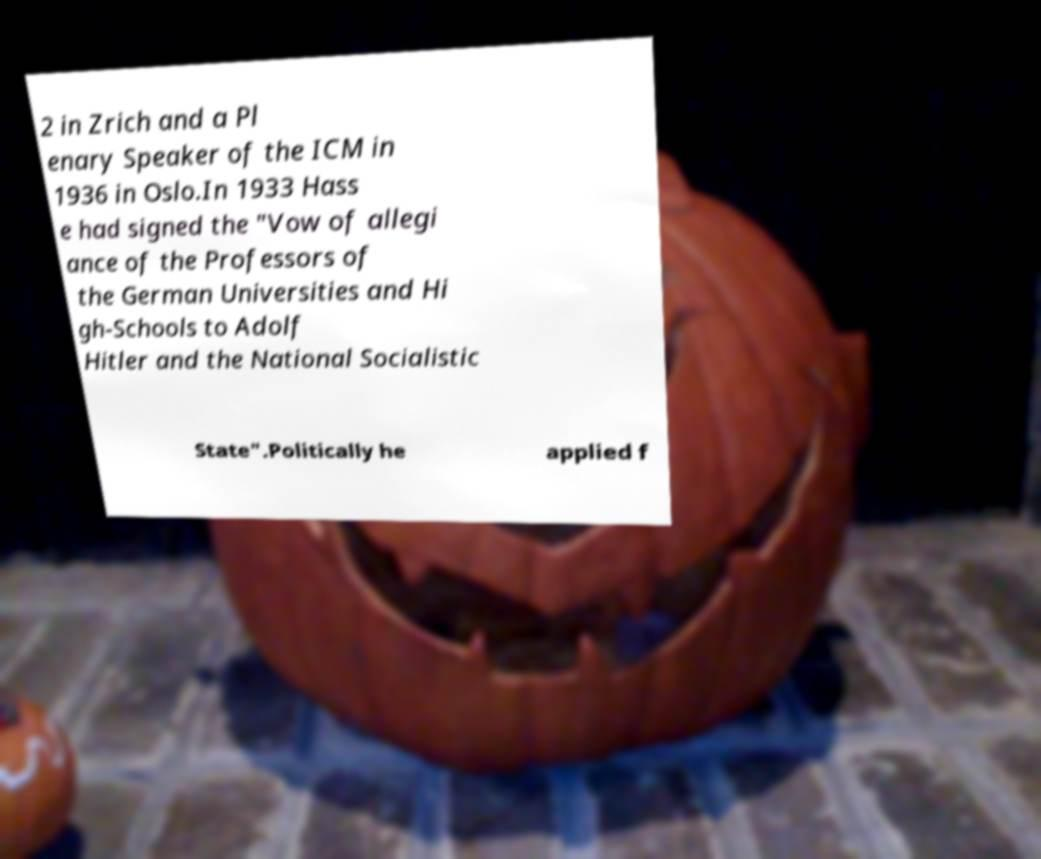Please read and relay the text visible in this image. What does it say? 2 in Zrich and a Pl enary Speaker of the ICM in 1936 in Oslo.In 1933 Hass e had signed the "Vow of allegi ance of the Professors of the German Universities and Hi gh-Schools to Adolf Hitler and the National Socialistic State".Politically he applied f 